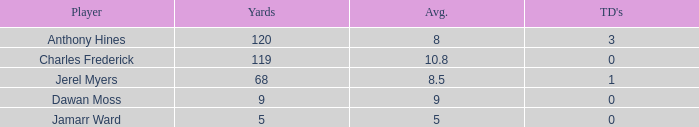What is the average number of TDs when the yards are less than 119, the AVG is larger than 5, and Jamarr Ward is a player? None. 